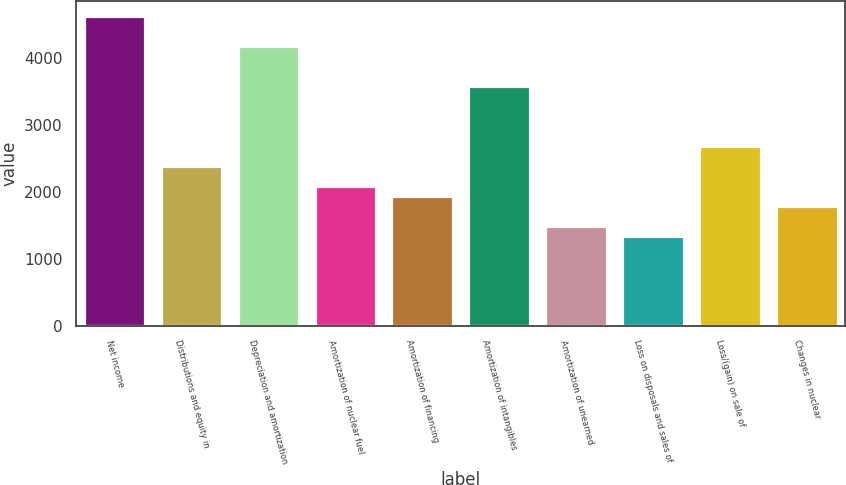<chart> <loc_0><loc_0><loc_500><loc_500><bar_chart><fcel>Net income<fcel>Distributions and equity in<fcel>Depreciation and amortization<fcel>Amortization of nuclear fuel<fcel>Amortization of financing<fcel>Amortization of intangibles<fcel>Amortization of unearned<fcel>Loss on disposals and sales of<fcel>Loss/(gain) on sale of<fcel>Changes in nuclear<nl><fcel>4629.3<fcel>2389.8<fcel>4181.4<fcel>2091.2<fcel>1941.9<fcel>3584.2<fcel>1494<fcel>1344.7<fcel>2688.4<fcel>1792.6<nl></chart> 